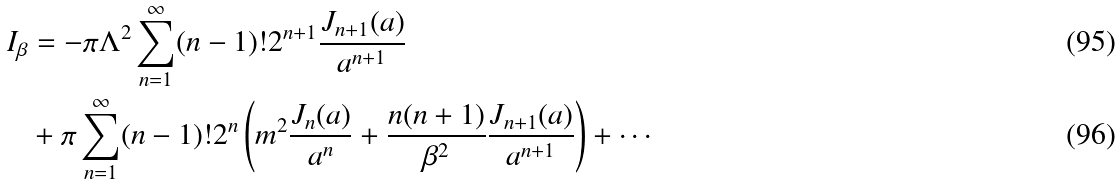Convert formula to latex. <formula><loc_0><loc_0><loc_500><loc_500>I _ { \beta } & = - \pi \Lambda ^ { 2 } \sum _ { n = 1 } ^ { \infty } ( n - 1 ) ! 2 ^ { n + 1 } \frac { J _ { n + 1 } ( a ) } { a ^ { n + 1 } } \\ & + \pi \sum _ { n = 1 } ^ { \infty } ( n - 1 ) ! 2 ^ { n } \left ( m ^ { 2 } \frac { J _ { n } ( a ) } { a ^ { n } } + \frac { n ( n + 1 ) } { \beta ^ { 2 } } \frac { J _ { n + 1 } ( a ) } { a ^ { n + 1 } } \right ) + \cdots</formula> 